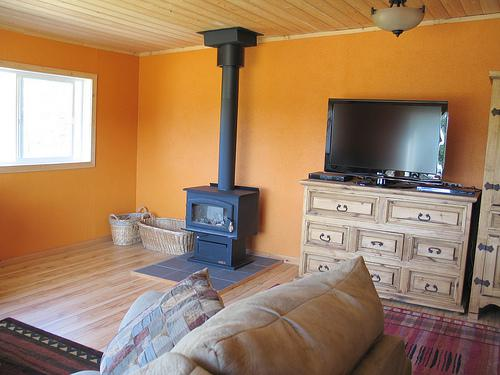Question: why was the picture taken?
Choices:
A. To capture the house.
B. To capture the property.
C. To capture the church.
D. To capture the room.
Answer with the letter. Answer: D Question: when was the picture taken?
Choices:
A. During the day.
B. During the night.
C. At dusk.
D. At dawn.
Answer with the letter. Answer: A Question: what color are the walls?
Choices:
A. White.
B. Orange.
C. Red.
D. Blue.
Answer with the letter. Answer: B Question: what is the television sitting on?
Choices:
A. A table.
B. The floor.
C. A dresser.
D. The wall.
Answer with the letter. Answer: C Question: who can be seen in the picture?
Choices:
A. Everyone.
B. No one.
C. A fireman.
D. A pastor.
Answer with the letter. Answer: B 